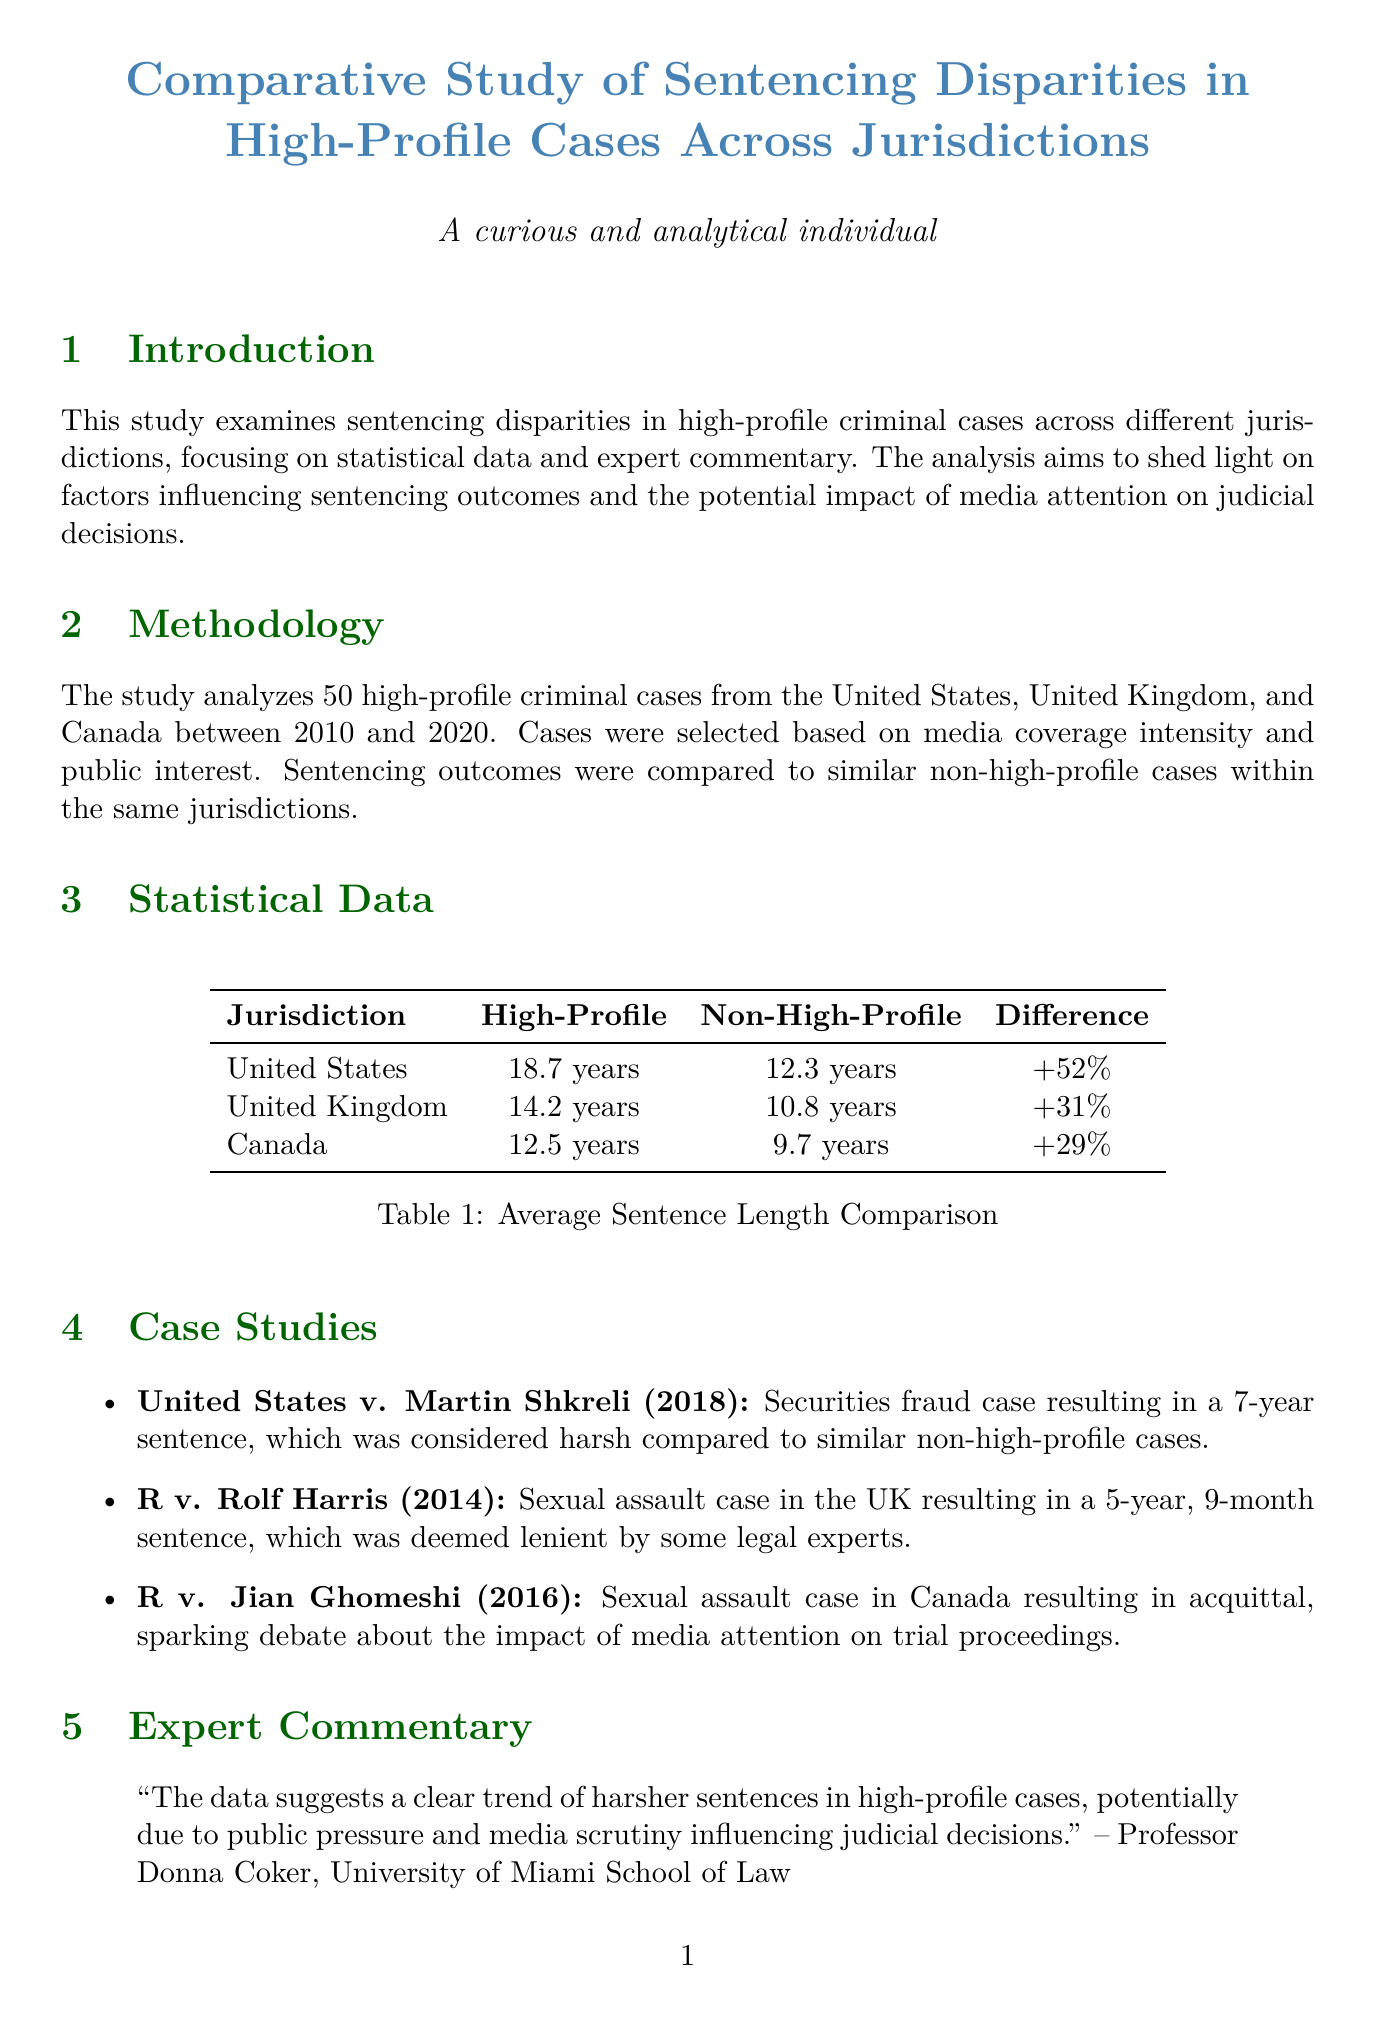What is the title of the study? The title of the study is presented at the beginning of the document, which is "Comparative Study of Sentencing Disparities in High-Profile Cases Across Jurisdictions."
Answer: Comparative Study of Sentencing Disparities in High-Profile Cases Across Jurisdictions What years does the study cover? The study analyzes cases from 2010 to 2020 as mentioned in the Methodology section.
Answer: 2010 to 2020 What is the average sentence length for high-profile cases in the United States? The statistical data table provides the average sentence length for high-profile cases in the United States, which is 18.7 years.
Answer: 18.7 years What is the percentage difference in average sentence length for high-profile cases compared to non-high-profile cases in Canada? The document states the percentage difference for Canada is 29%, which indicates the disparity between the two case types.
Answer: +29% Which case resulted in a 7-year sentence? The Case Studies section lists "United States v. Martin Shkreli (2018)" as the case that resulted in a 7-year sentence.
Answer: United States v. Martin Shkreli (2018) Who provided commentary on sentencing inflation in the UK? The document includes a quote from Barrister Helena Kennedy QC, who commented on sentencing inflation in the UK.
Answer: Barrister Helena Kennedy QC What is one of the factors influencing sentencing disparities? The section detailing the influencing factors lists several, including "Media pressure and public opinion" as one of them.
Answer: Media pressure and public opinion What recommendation is made to address sentencing disparities? The Implications and Recommendations section suggests "enhanced judicial training on media influence" as a key recommendation.
Answer: Enhanced judicial training on media influence 